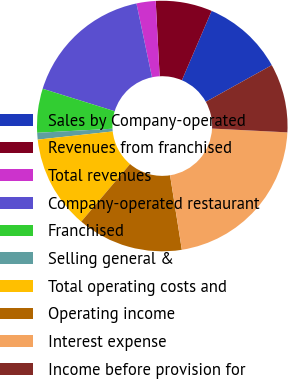Convert chart. <chart><loc_0><loc_0><loc_500><loc_500><pie_chart><fcel>Sales by Company-operated<fcel>Revenues from franchised<fcel>Total revenues<fcel>Company-operated restaurant<fcel>Franchised<fcel>Selling general &<fcel>Total operating costs and<fcel>Operating income<fcel>Interest expense<fcel>Income before provision for<nl><fcel>10.48%<fcel>7.28%<fcel>2.47%<fcel>16.89%<fcel>5.67%<fcel>0.87%<fcel>12.08%<fcel>13.69%<fcel>21.7%<fcel>8.88%<nl></chart> 